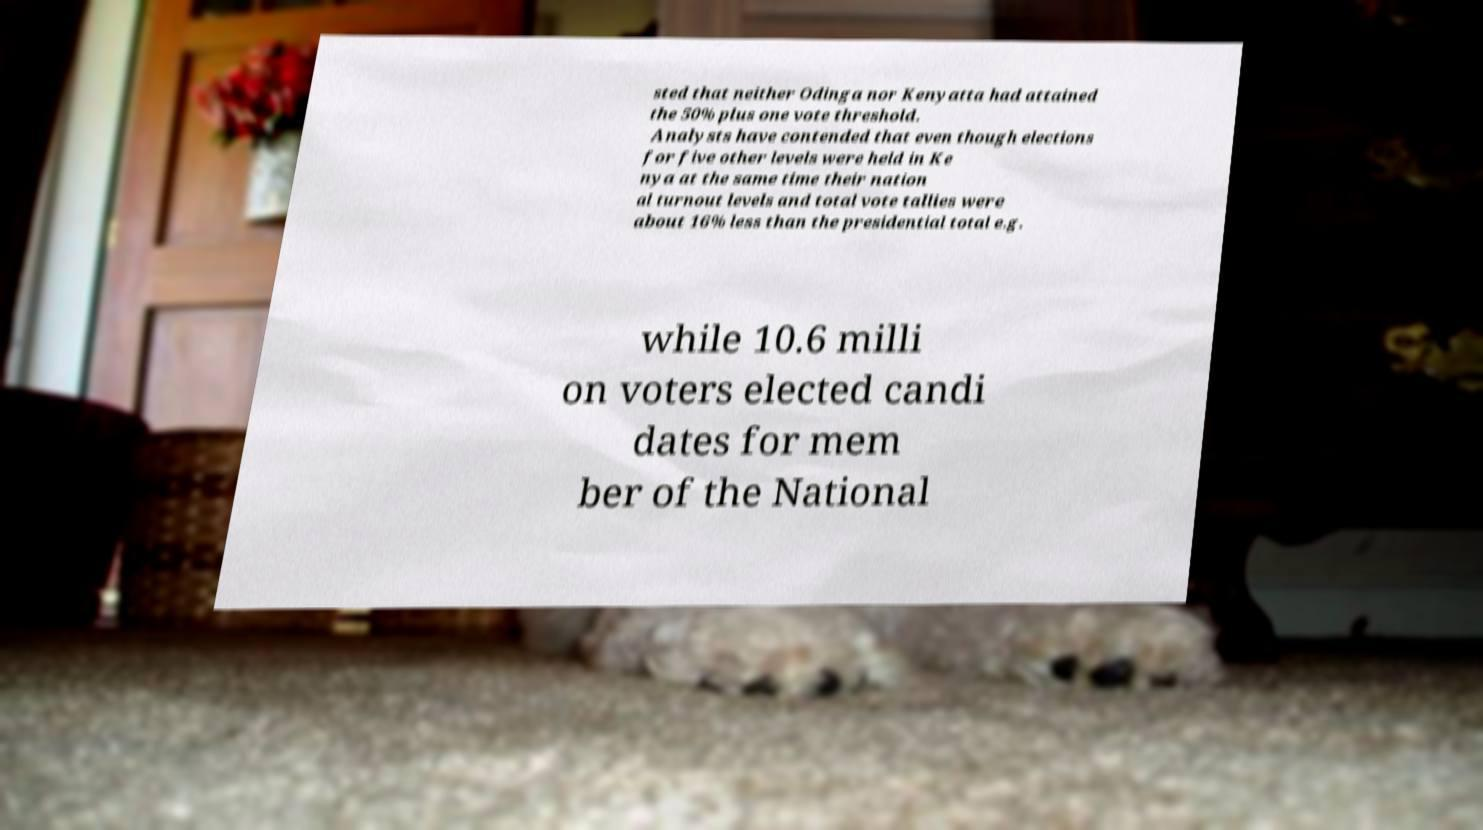Can you read and provide the text displayed in the image?This photo seems to have some interesting text. Can you extract and type it out for me? sted that neither Odinga nor Kenyatta had attained the 50% plus one vote threshold. Analysts have contended that even though elections for five other levels were held in Ke nya at the same time their nation al turnout levels and total vote tallies were about 16% less than the presidential total e.g. while 10.6 milli on voters elected candi dates for mem ber of the National 